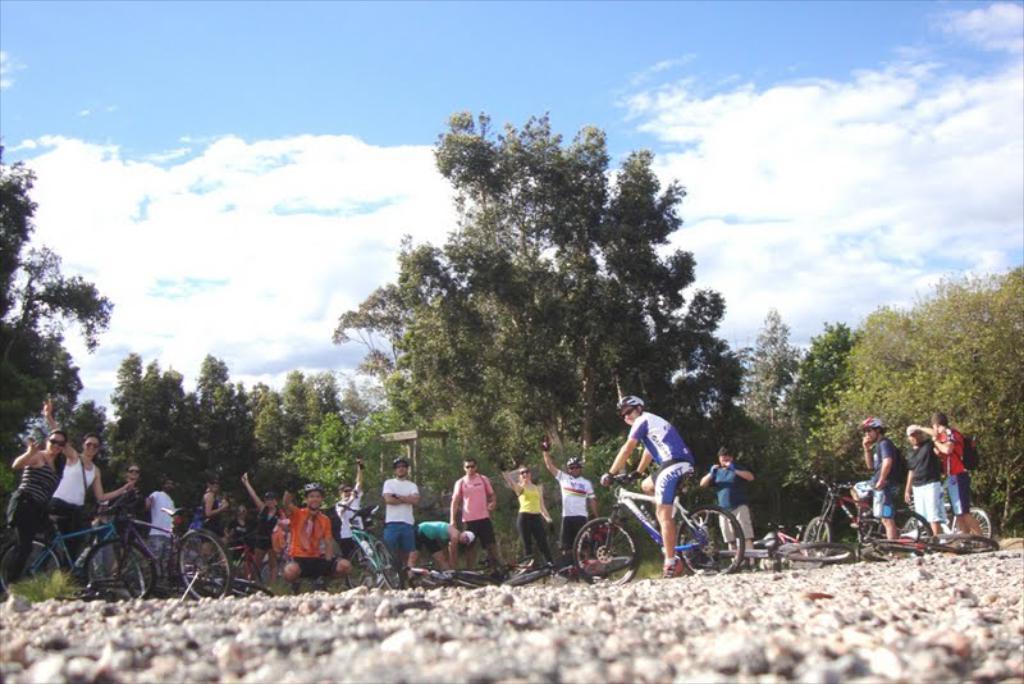Please provide a concise description of this image. Here in this picture we can see number of people standing on the ground over there and we can also see some bicycles present on the ground and we can see some people are sitting on bicycles, with helmets and goggles on them and behind them we can see trees and plants present all over there and we can see clouds in the sky. 